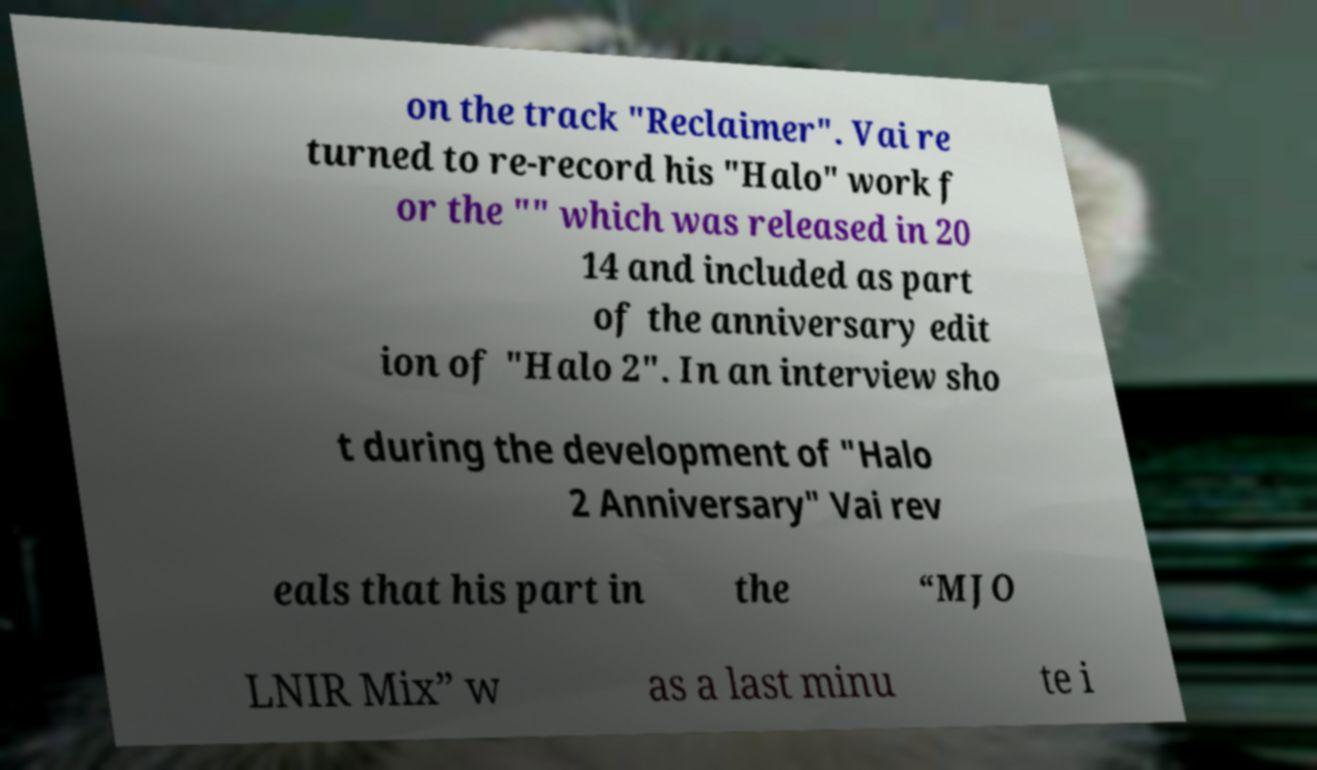Can you read and provide the text displayed in the image?This photo seems to have some interesting text. Can you extract and type it out for me? on the track "Reclaimer". Vai re turned to re-record his "Halo" work f or the "" which was released in 20 14 and included as part of the anniversary edit ion of "Halo 2". In an interview sho t during the development of "Halo 2 Anniversary" Vai rev eals that his part in the “MJO LNIR Mix” w as a last minu te i 